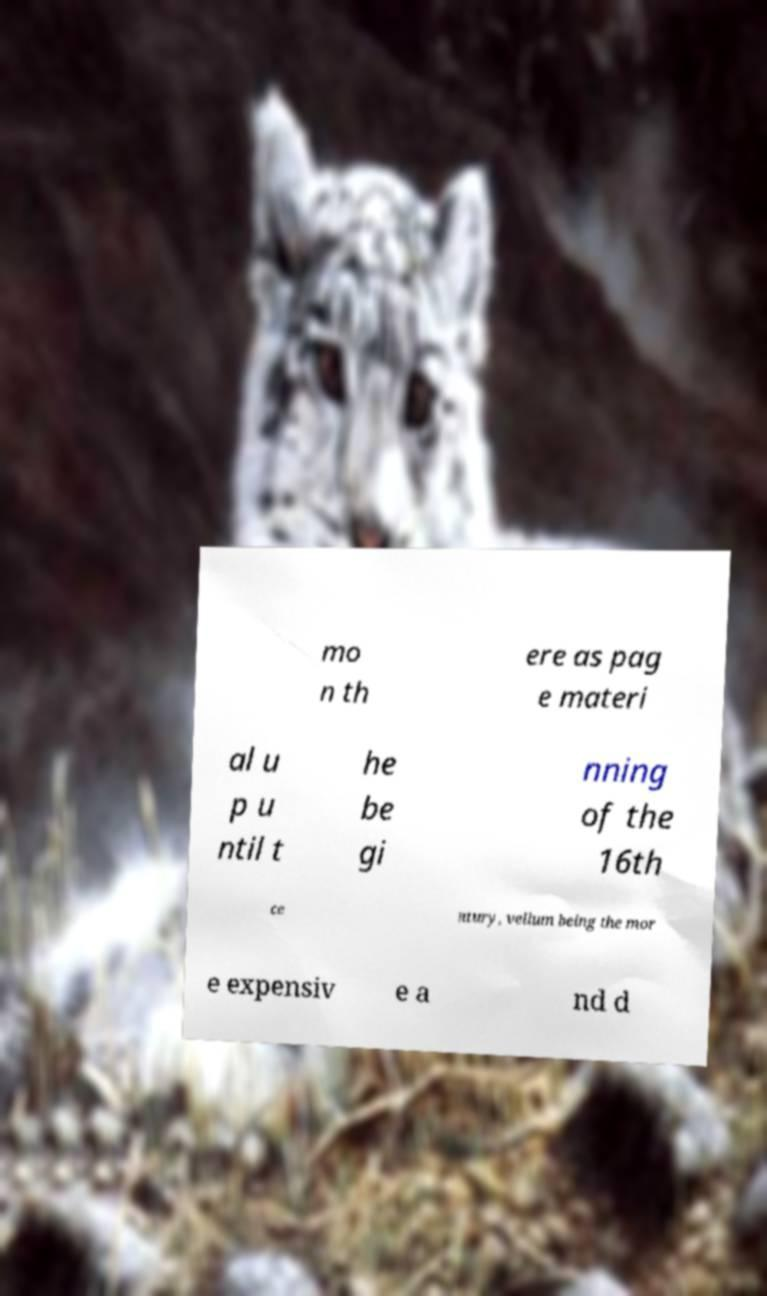What messages or text are displayed in this image? I need them in a readable, typed format. mo n th ere as pag e materi al u p u ntil t he be gi nning of the 16th ce ntury, vellum being the mor e expensiv e a nd d 